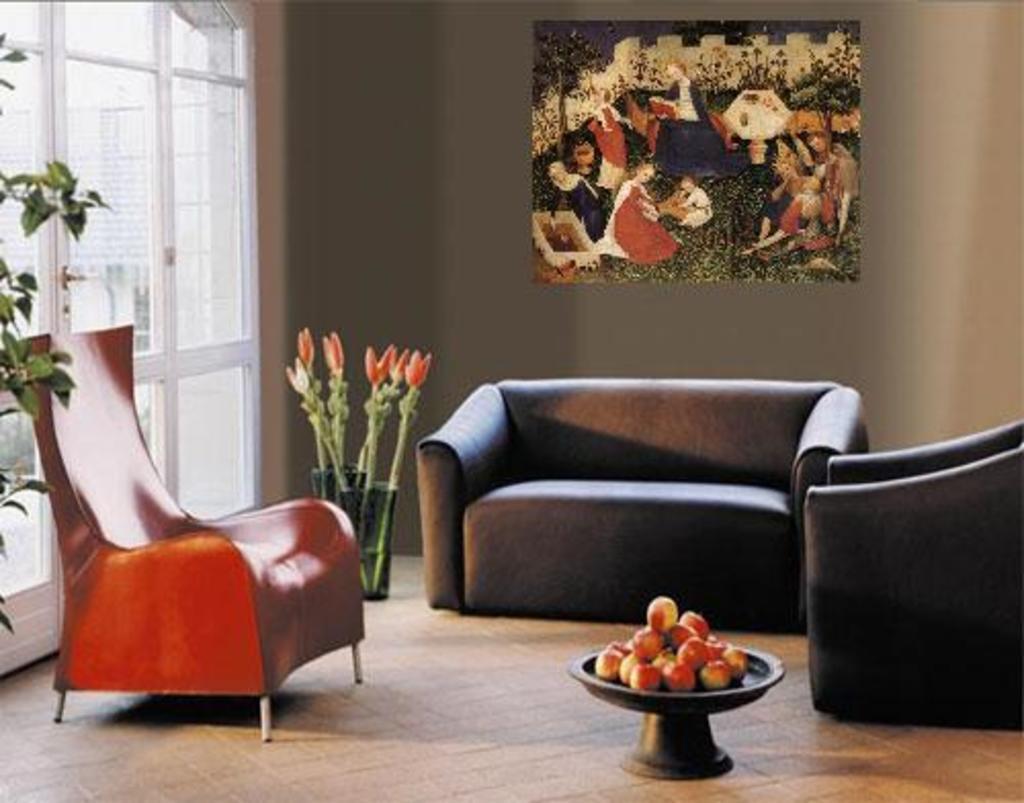How would you summarize this image in a sentence or two? This image is clicked in a room. There are chairs and sofa. There is a painting on the wall. There is a plant on the left side and in the middle. There are fruits in the middle. There is a door on the left side. 